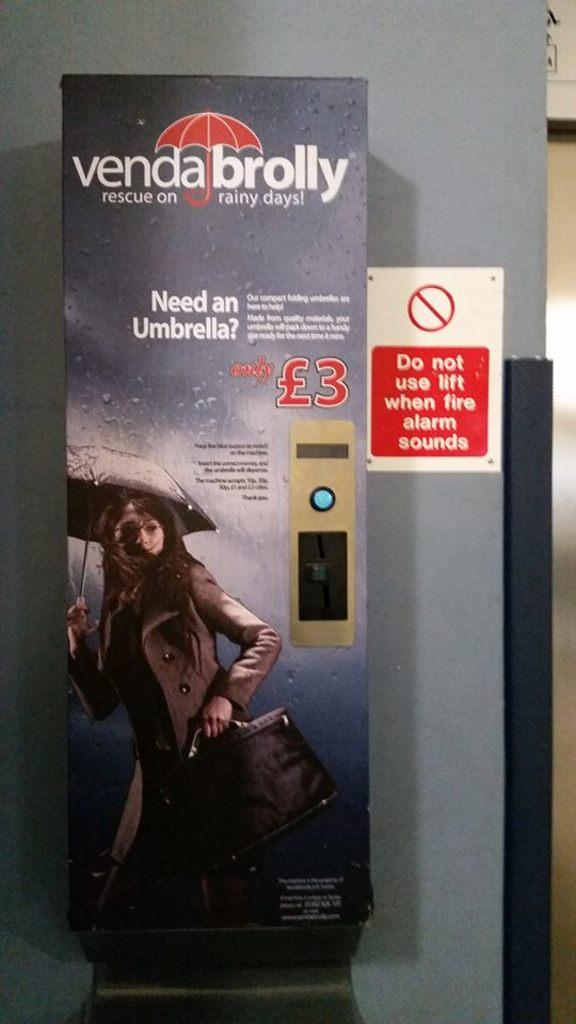What is the main subject of the image? The main subject of the image is an advertisement. Can you describe the setting in which the advertisement is located? There is a board on the wall in the image, which suggests that the advertisement is displayed on a wall. How does the house in the image withstand the strong wind? There is no house or wind present in the image; it only features an advertisement on a board on the wall. 